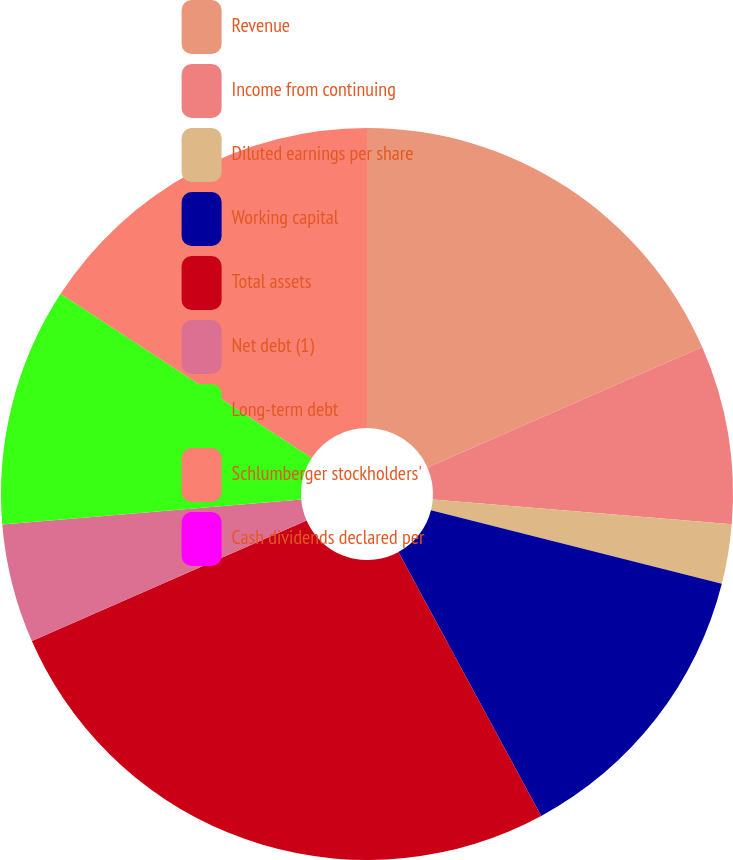Convert chart to OTSL. <chart><loc_0><loc_0><loc_500><loc_500><pie_chart><fcel>Revenue<fcel>Income from continuing<fcel>Diluted earnings per share<fcel>Working capital<fcel>Total assets<fcel>Net debt (1)<fcel>Long-term debt<fcel>Schlumberger stockholders'<fcel>Cash dividends declared per<nl><fcel>18.42%<fcel>7.89%<fcel>2.63%<fcel>13.16%<fcel>26.31%<fcel>5.26%<fcel>10.53%<fcel>15.79%<fcel>0.0%<nl></chart> 